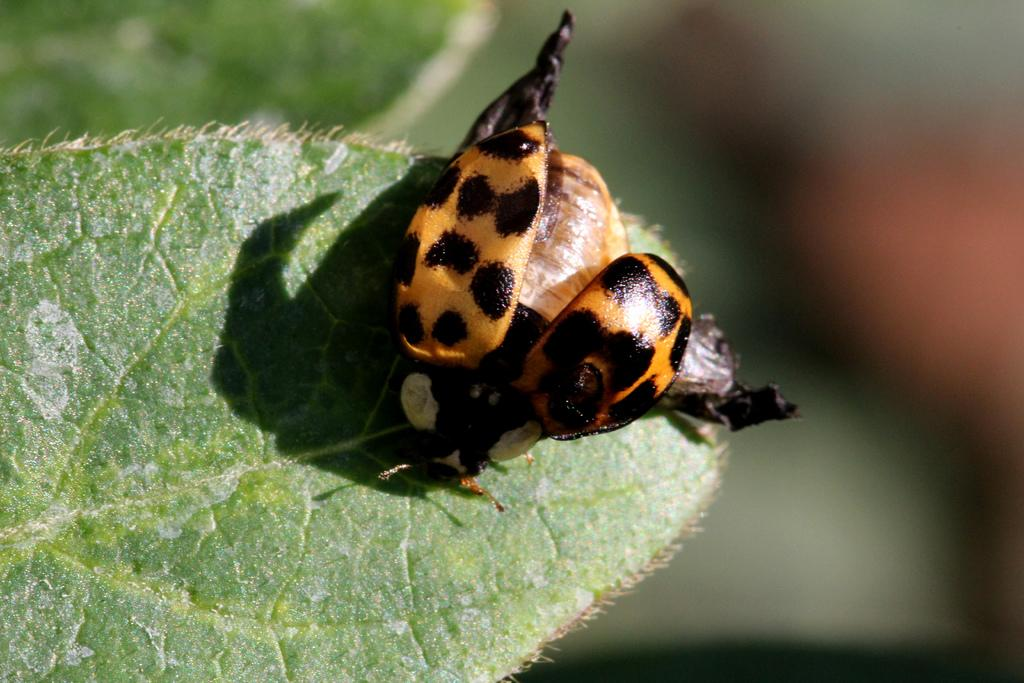What insect is present in the image? There is a ladybug in the image. Where is the ladybug located? The ladybug is on a leaf. Can you describe the background of the image? The background of the image is blurry. What holiday is the ladybug celebrating in the image? There is no indication of a holiday in the image; it simply features a ladybug on a leaf. 